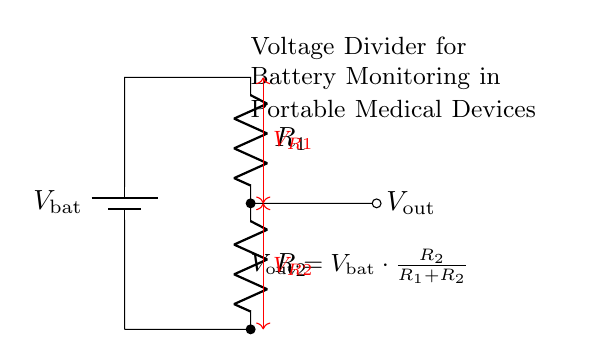What type of circuit is this? This circuit is a voltage divider, which is specifically designed to divide the input voltage into smaller output voltages based on the resistor values.
Answer: Voltage divider What is the formula for the output voltage? The output voltage is determined by the formula derived from the voltage divider rule: V out equals V bat multiplied by R2 divided by the sum of R1 and R2.
Answer: V out = V bat * R2 / (R1 + R2) What are the components used in this circuit? The components are represented as elements in the diagram: one battery and two resistors. This setup allows for voltage measurement.
Answer: Battery and two resistors What is the symbol for the battery in this circuit? The battery is denoted by a specific symbol that represents a source of voltage, typically depicted with long and short parallel lines, indicating its positive and negative terminals.
Answer: Battery symbol What is the relationship between R1 and R2 in terms of voltage division? R1 and R2 create a specific ratio that determines V out; as R2 increases relative to R1, V out increases, showing an inverse relationship to R1.
Answer: V out is proportional to R2 and inversely proportional to R1 What does V out represent in this circuit? V out is the output voltage across R2, which is the voltage level used for monitoring battery levels in portable devices.
Answer: Output voltage across R2 